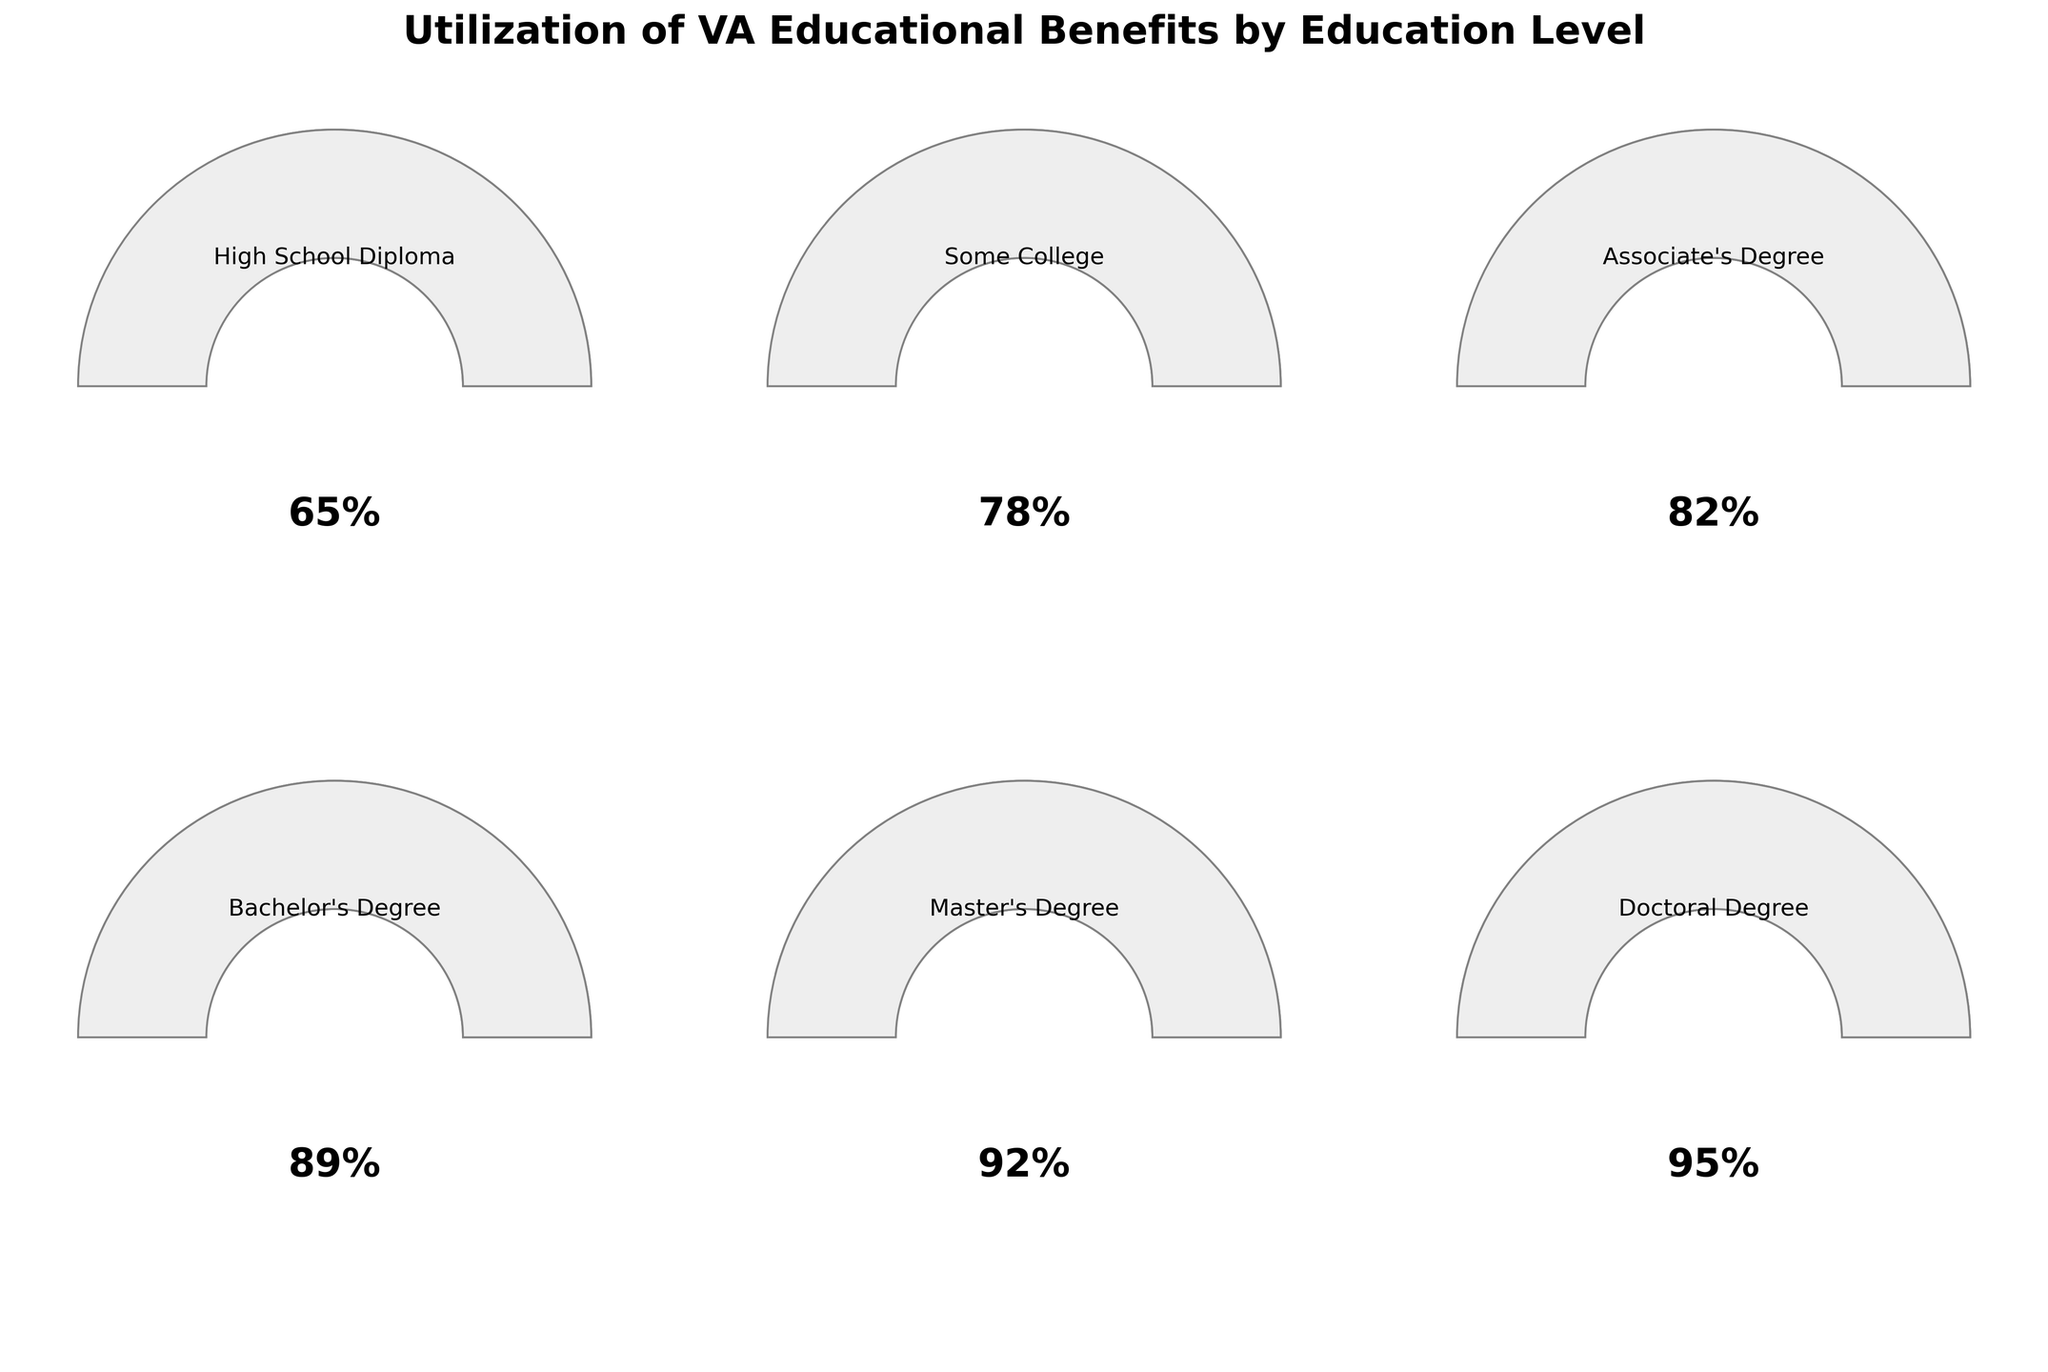What is the title of the figure? The title of the figure is usually displayed prominently at the top. In this case, the title reads "Utilization of VA Educational Benefits by Education Level".
Answer: Utilization of VA Educational Benefits by Education Level How many education levels are represented in the figure? By visually counting the number of gauge charts, you can see there are six distinct gauge charts, each representing a different education level.
Answer: Six Which education level has the highest utilization percentage? By comparing the percentage values displayed in each gauge chart, the one with the highest value is the Doctoral Degree with 95%.
Answer: Doctoral Degree What is the utilization percentage for a Bachelor's Degree? Locate the gauge chart labeled "Bachelor's Degree" and note the percentage text within it. It shows 89%.
Answer: 89% What is the difference in utilization percentage between a Master's Degree and an Associate's Degree? Identify the utilization percentages for a Master's Degree (92%) and an Associate's Degree (82%). Subtract the smaller value from the larger one: 92% - 82%.
Answer: 10% What is the average utilization percentage for all education levels? Add all the utilization percentages: 65% + 78% + 82% + 89% + 92% + 95%, and then divide by the number of education levels, which is 6. (65 + 78 + 82 + 89 + 92 + 95)/6 = 501/6.
Answer: 83.5% Which education level shows a utilization percentage that is less than 80%? Compare each education level’s utilization percentage with 80%. High School Diploma (65%) and Some College (78%) are both less than 80%.
Answer: High School Diploma, Some College What is the utilization percentage range present in the figure? Identify the lowest and highest utilization percentages: High School Diploma (65%) and Doctoral Degree (95%). The range is 95% - 65%.
Answer: 30% Which education levels have a utilization percentage greater than 80%? Compare each education level’s utilization percentage value with 80%. Associate's Degree (82%), Bachelor's Degree (89%), Master’s Degree (92%), and Doctoral Degree (95%) are all greater than 80%.
Answer: Associate's Degree, Bachelor's Degree, Master’s Degree, Doctoral Degree 